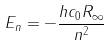<formula> <loc_0><loc_0><loc_500><loc_500>E _ { n } = - \frac { h c _ { 0 } R _ { \infty } } { n ^ { 2 } }</formula> 